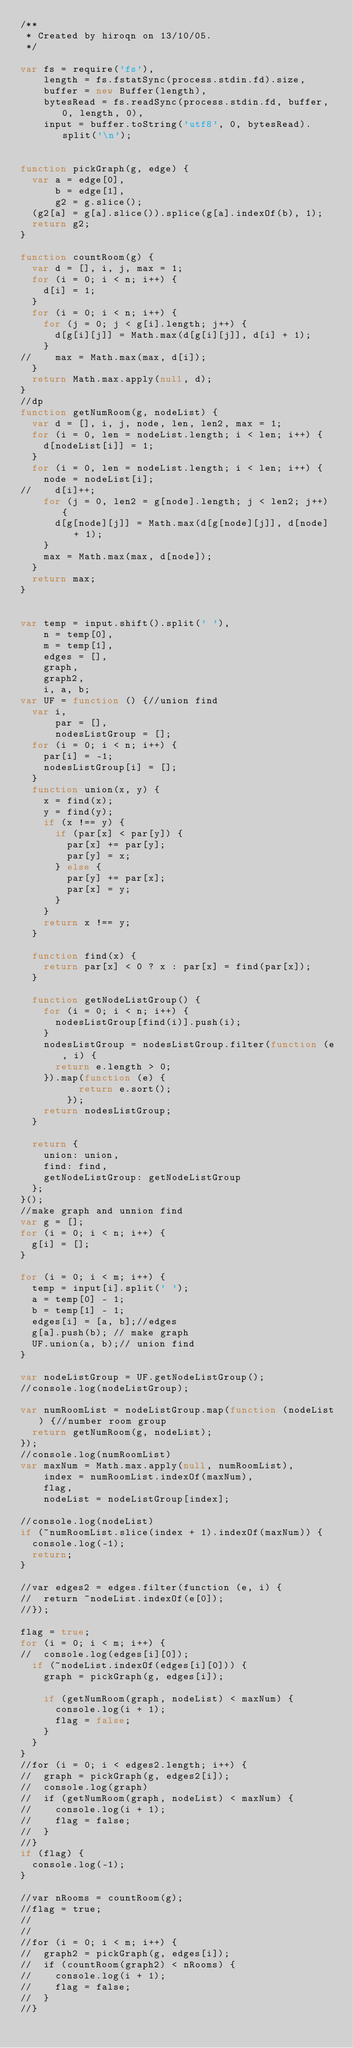Convert code to text. <code><loc_0><loc_0><loc_500><loc_500><_JavaScript_>/**
 * Created by hiroqn on 13/10/05.
 */

var fs = require('fs'),
    length = fs.fstatSync(process.stdin.fd).size,
    buffer = new Buffer(length),
    bytesRead = fs.readSync(process.stdin.fd, buffer, 0, length, 0),
    input = buffer.toString('utf8', 0, bytesRead).split('\n');


function pickGraph(g, edge) {
  var a = edge[0],
      b = edge[1],
      g2 = g.slice();
  (g2[a] = g[a].slice()).splice(g[a].indexOf(b), 1);
  return g2;
}

function countRoom(g) {
  var d = [], i, j, max = 1;
  for (i = 0; i < n; i++) {
    d[i] = 1;
  }
  for (i = 0; i < n; i++) {
    for (j = 0; j < g[i].length; j++) {
      d[g[i][j]] = Math.max(d[g[i][j]], d[i] + 1);
    }
//    max = Math.max(max, d[i]);
  }
  return Math.max.apply(null, d);
}
//dp
function getNumRoom(g, nodeList) {
  var d = [], i, j, node, len, len2, max = 1;
  for (i = 0, len = nodeList.length; i < len; i++) {
    d[nodeList[i]] = 1;
  }
  for (i = 0, len = nodeList.length; i < len; i++) {
    node = nodeList[i];
//    d[i]++;
    for (j = 0, len2 = g[node].length; j < len2; j++) {
      d[g[node][j]] = Math.max(d[g[node][j]], d[node] + 1);
    }
    max = Math.max(max, d[node]);
  }
  return max;
}


var temp = input.shift().split(' '),
    n = temp[0],
    m = temp[1],
    edges = [],
    graph,
    graph2,
    i, a, b;
var UF = function () {//union find
  var i,
      par = [],
      nodesListGroup = [];
  for (i = 0; i < n; i++) {
    par[i] = -1;
    nodesListGroup[i] = [];
  }
  function union(x, y) {
    x = find(x);
    y = find(y);
    if (x !== y) {
      if (par[x] < par[y]) {
        par[x] += par[y];
        par[y] = x;
      } else {
        par[y] += par[x];
        par[x] = y;
      }
    }
    return x !== y;
  }

  function find(x) {
    return par[x] < 0 ? x : par[x] = find(par[x]);
  }

  function getNodeListGroup() {
    for (i = 0; i < n; i++) {
      nodesListGroup[find(i)].push(i);
    }
    nodesListGroup = nodesListGroup.filter(function (e, i) {
      return e.length > 0;
    }).map(function (e) {
          return e.sort();
        });
    return nodesListGroup;
  }

  return {
    union: union,
    find: find,
    getNodeListGroup: getNodeListGroup
  };
}();
//make graph and unnion find
var g = [];
for (i = 0; i < n; i++) {
  g[i] = [];
}

for (i = 0; i < m; i++) {
  temp = input[i].split(' ');
  a = temp[0] - 1;
  b = temp[1] - 1;
  edges[i] = [a, b];//edges
  g[a].push(b); // make graph
  UF.union(a, b);// union find
}

var nodeListGroup = UF.getNodeListGroup();
//console.log(nodeListGroup);

var numRoomList = nodeListGroup.map(function (nodeList) {//number room group
  return getNumRoom(g, nodeList);
});
//console.log(numRoomList)
var maxNum = Math.max.apply(null, numRoomList),
    index = numRoomList.indexOf(maxNum),
    flag,
    nodeList = nodeListGroup[index];

//console.log(nodeList)
if (~numRoomList.slice(index + 1).indexOf(maxNum)) {
  console.log(-1);
  return;
}

//var edges2 = edges.filter(function (e, i) {
//  return ~nodeList.indexOf(e[0]);
//});

flag = true;
for (i = 0; i < m; i++) {
//  console.log(edges[i][0]);
  if (~nodeList.indexOf(edges[i][0])) {
    graph = pickGraph(g, edges[i]);

    if (getNumRoom(graph, nodeList) < maxNum) {
      console.log(i + 1);
      flag = false;
    }
  }
}
//for (i = 0; i < edges2.length; i++) {
//  graph = pickGraph(g, edges2[i]);
//  console.log(graph)
//  if (getNumRoom(graph, nodeList) < maxNum) {
//    console.log(i + 1);
//    flag = false;
//  }
//}
if (flag) {
  console.log(-1);
}

//var nRooms = countRoom(g);
//flag = true;
//
//
//for (i = 0; i < m; i++) {
//  graph2 = pickGraph(g, edges[i]);
//  if (countRoom(graph2) < nRooms) {
//    console.log(i + 1);
//    flag = false;
//  }
//}</code> 